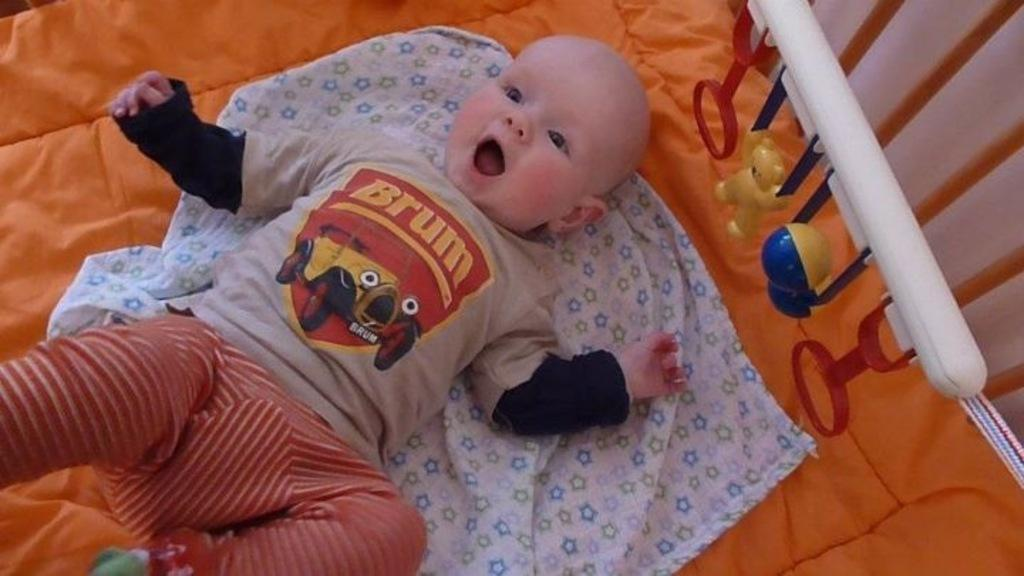What is the main subject of the image? There is a baby lying in the image. What else can be seen in the image besides the baby? There are clothes, a white colored object, toys, a wall, and poles on the right side of the image. What place does the girl receive a reward for her achievements in the image? There is no girl or reward present in the image. 